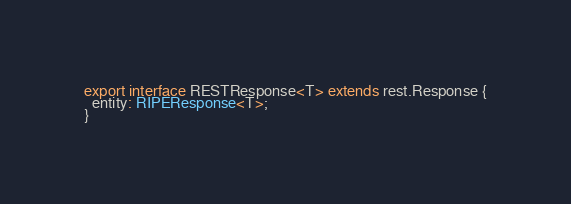<code> <loc_0><loc_0><loc_500><loc_500><_TypeScript_>export interface RESTResponse<T> extends rest.Response {
  entity: RIPEResponse<T>;
}
</code> 